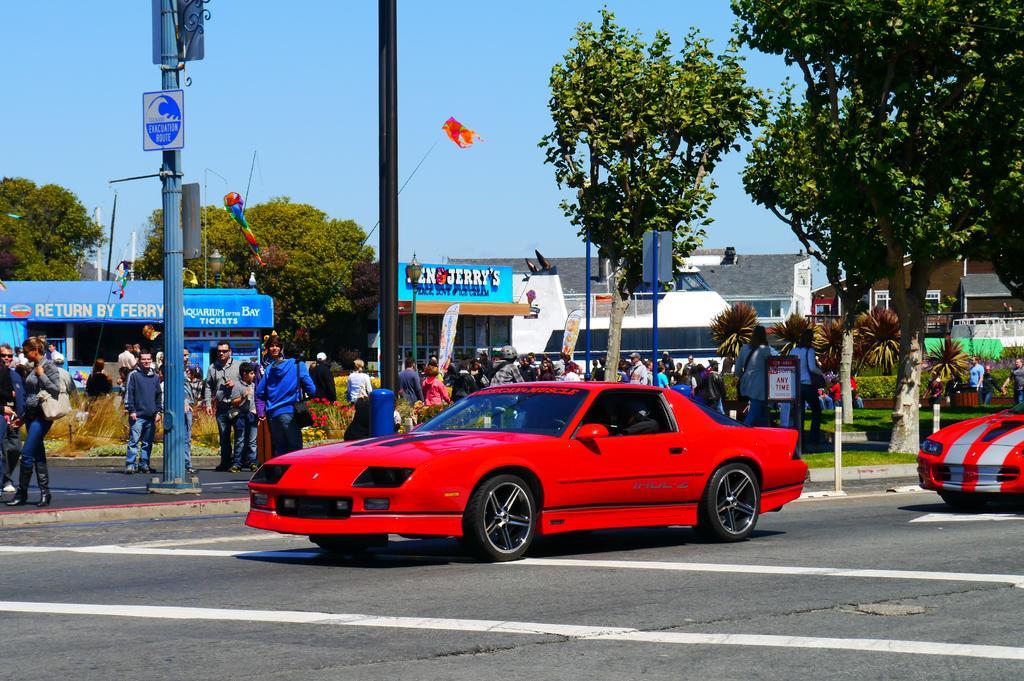Describe this image in one or two sentences. In this image there are some cars riding on the road, beside that there are people standing and also there are some electrical poles, buildings and trees. 